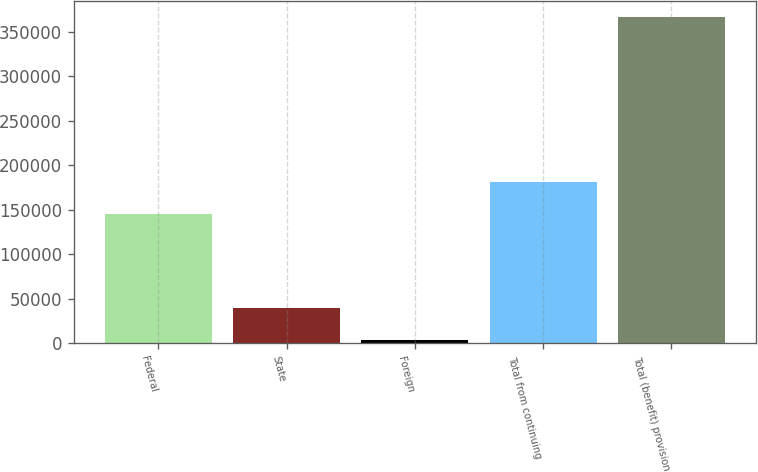<chart> <loc_0><loc_0><loc_500><loc_500><bar_chart><fcel>Federal<fcel>State<fcel>Foreign<fcel>Total from continuing<fcel>Total (benefit) provision<nl><fcel>144990<fcel>39832.9<fcel>3517<fcel>181306<fcel>366676<nl></chart> 